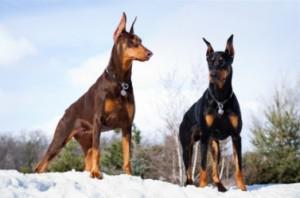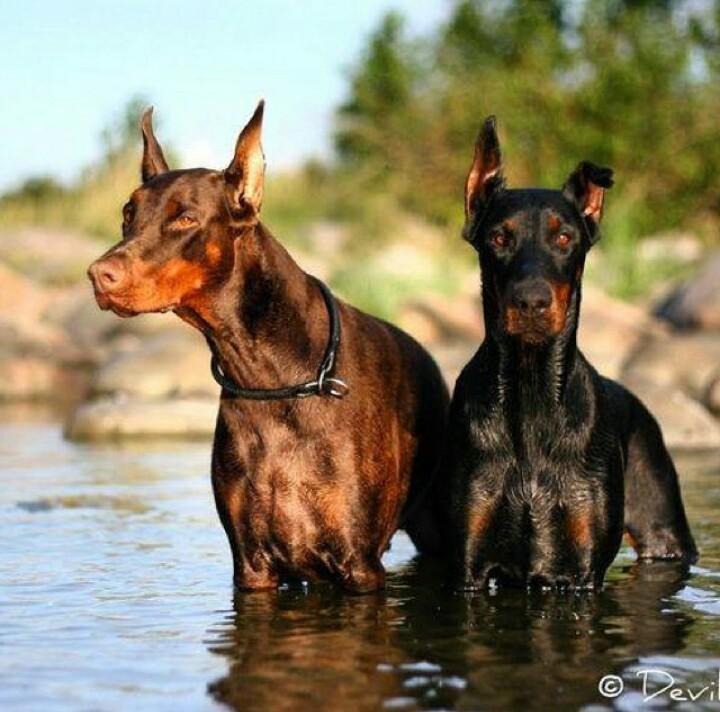The first image is the image on the left, the second image is the image on the right. Given the left and right images, does the statement "There are exactly four dogs in total." hold true? Answer yes or no. Yes. 